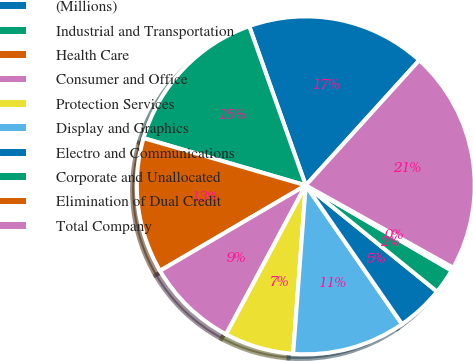<chart> <loc_0><loc_0><loc_500><loc_500><pie_chart><fcel>(Millions)<fcel>Industrial and Transportation<fcel>Health Care<fcel>Consumer and Office<fcel>Protection Services<fcel>Display and Graphics<fcel>Electro and Communications<fcel>Corporate and Unallocated<fcel>Elimination of Dual Credit<fcel>Total Company<nl><fcel>17.16%<fcel>15.06%<fcel>12.95%<fcel>8.74%<fcel>6.63%<fcel>10.84%<fcel>4.52%<fcel>2.41%<fcel>0.31%<fcel>21.38%<nl></chart> 